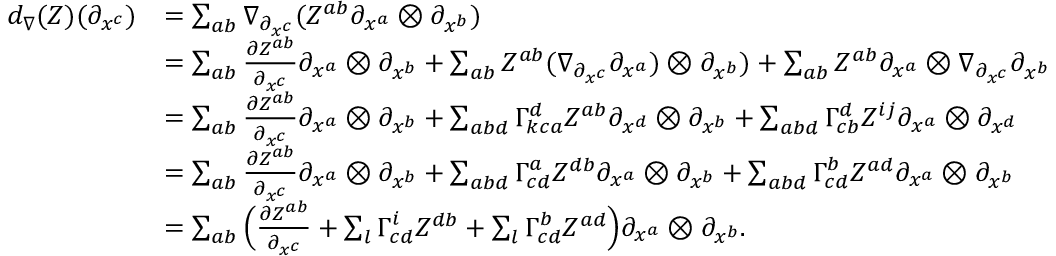<formula> <loc_0><loc_0><loc_500><loc_500>\begin{array} { r l } { d _ { \nabla } ( Z ) ( \partial _ { x ^ { c } } ) } & { = \sum _ { a b } \nabla _ { \partial _ { x ^ { c } } } ( Z ^ { a b } \partial _ { x ^ { a } } \otimes \partial _ { x ^ { b } } ) } \\ & { = \sum _ { a b } \frac { \partial Z ^ { a b } } { \partial _ { x ^ { c } } } \partial _ { x ^ { a } } \otimes \partial _ { x ^ { b } } + \sum _ { a b } Z ^ { a b } ( \nabla _ { \partial _ { x ^ { c } } } \partial _ { x ^ { a } } ) \otimes \partial _ { x ^ { b } } ) + \sum _ { a b } Z ^ { a b } \partial _ { x ^ { a } } \otimes \nabla _ { \partial _ { x ^ { c } } } \partial _ { x ^ { b } } } \\ & { = \sum _ { a b } \frac { \partial Z ^ { a b } } { \partial _ { x ^ { c } } } \partial _ { x ^ { a } } \otimes \partial _ { x ^ { b } } + \sum _ { a b d } \Gamma _ { k c a } ^ { d } Z ^ { a b } \partial _ { x ^ { d } } \otimes \partial _ { x ^ { b } } + \sum _ { a b d } \Gamma _ { c b } ^ { d } Z ^ { i j } \partial _ { x ^ { a } } \otimes \partial _ { x ^ { d } } } \\ & { = \sum _ { a b } \frac { \partial Z ^ { a b } } { \partial _ { x ^ { c } } } \partial _ { x ^ { a } } \otimes \partial _ { x ^ { b } } + \sum _ { a b d } \Gamma _ { c d } ^ { a } Z ^ { d b } \partial _ { x ^ { a } } \otimes \partial _ { x ^ { b } } + \sum _ { a b d } \Gamma _ { c d } ^ { b } Z ^ { a d } \partial _ { x ^ { a } } \otimes \partial _ { x ^ { b } } } \\ & { = \sum _ { a b } \left ( \frac { \partial Z ^ { a b } } { \partial _ { x ^ { c } } } + \sum _ { l } \Gamma _ { c d } ^ { i } Z ^ { d b } + \sum _ { l } \Gamma _ { c d } ^ { b } Z ^ { a d } \right ) \partial _ { x ^ { a } } \otimes \partial _ { x ^ { b } } . } \end{array}</formula> 